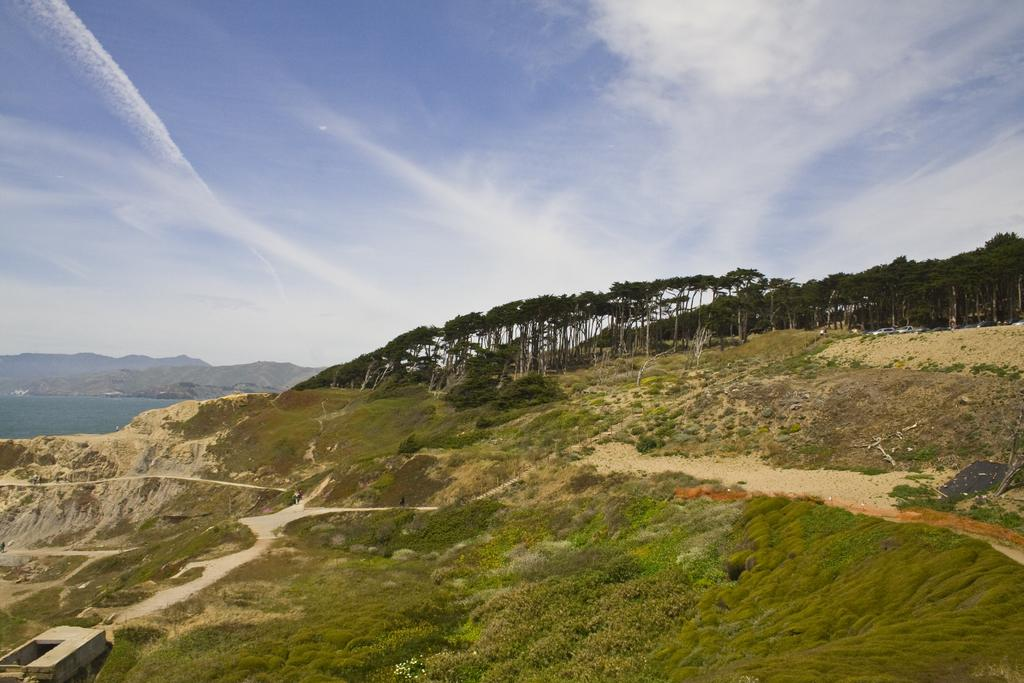What type of vegetation is present in the image? There is grass, plants, and trees in the image. What can be seen on the left side of the image? There is water and a mountain on the left side of the image. What is visible in the background of the image? The sky is visible in the background of the image. What type of payment is being made in the image? There is no payment being made in the image. Can you see a drum in the image? There is no drum present in the image. 